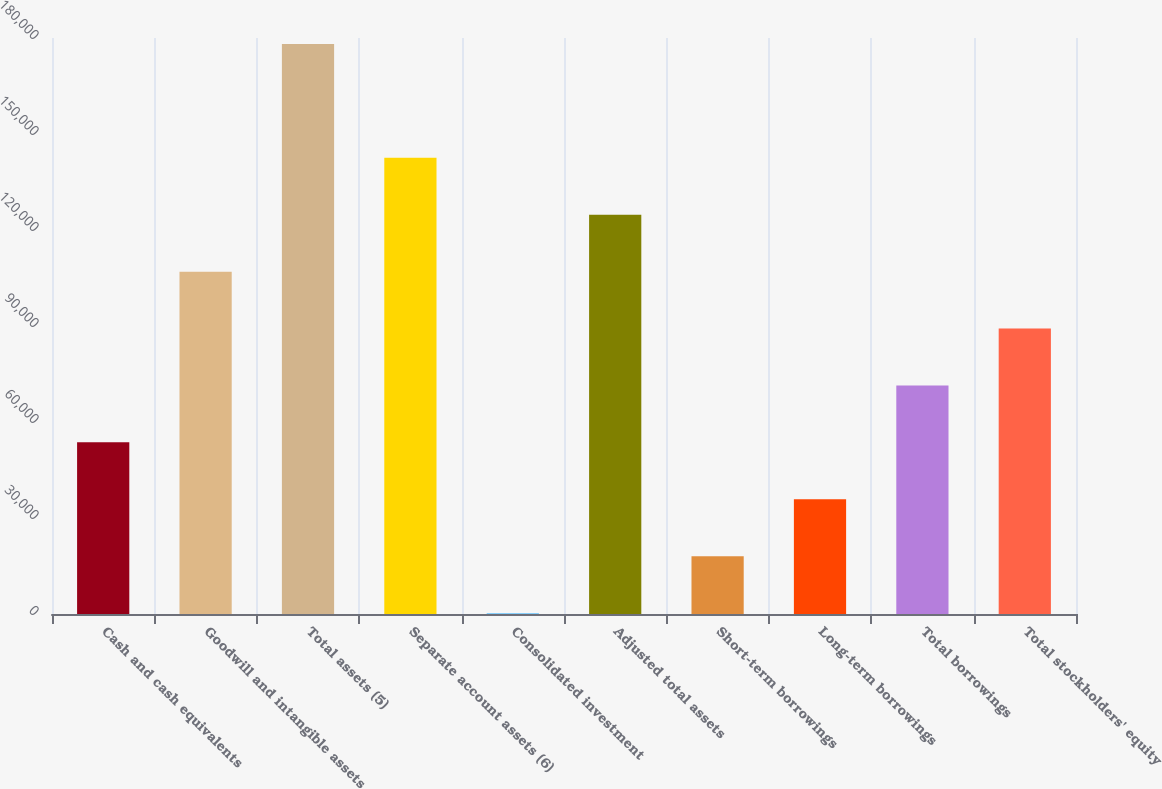Convert chart. <chart><loc_0><loc_0><loc_500><loc_500><bar_chart><fcel>Cash and cash equivalents<fcel>Goodwill and intangible assets<fcel>Total assets (5)<fcel>Separate account assets (6)<fcel>Consolidated investment<fcel>Adjusted total assets<fcel>Short-term borrowings<fcel>Long-term borrowings<fcel>Total borrowings<fcel>Total stockholders' equity<nl><fcel>53634.6<fcel>106987<fcel>178124<fcel>142556<fcel>282<fcel>124771<fcel>18066.2<fcel>35850.4<fcel>71418.8<fcel>89203<nl></chart> 